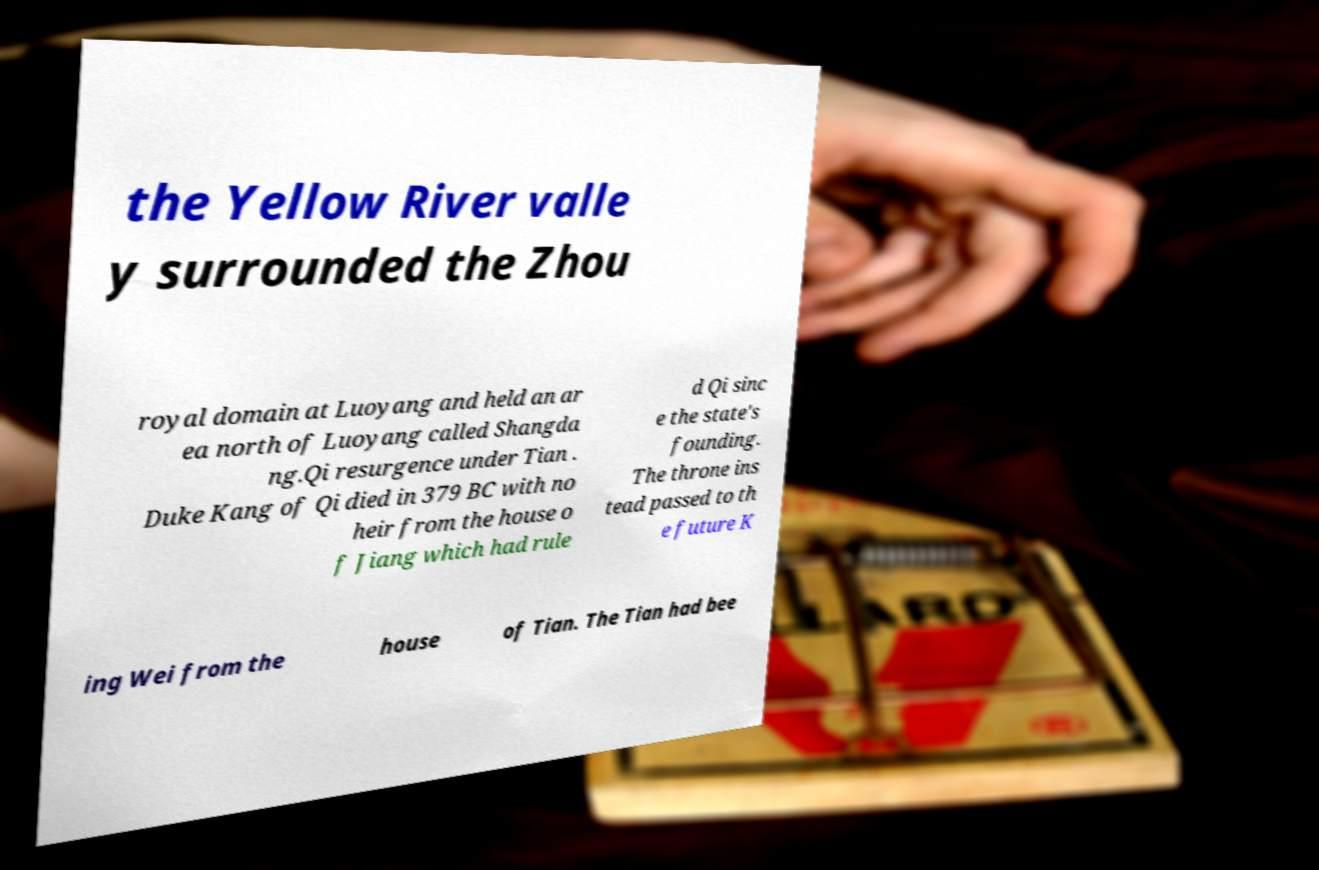Please identify and transcribe the text found in this image. the Yellow River valle y surrounded the Zhou royal domain at Luoyang and held an ar ea north of Luoyang called Shangda ng.Qi resurgence under Tian . Duke Kang of Qi died in 379 BC with no heir from the house o f Jiang which had rule d Qi sinc e the state's founding. The throne ins tead passed to th e future K ing Wei from the house of Tian. The Tian had bee 